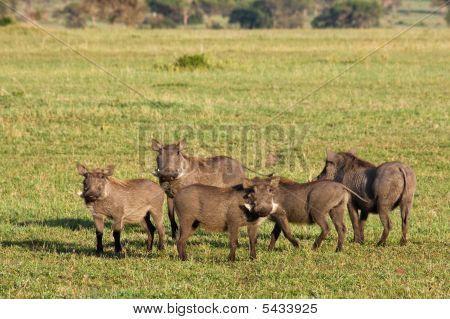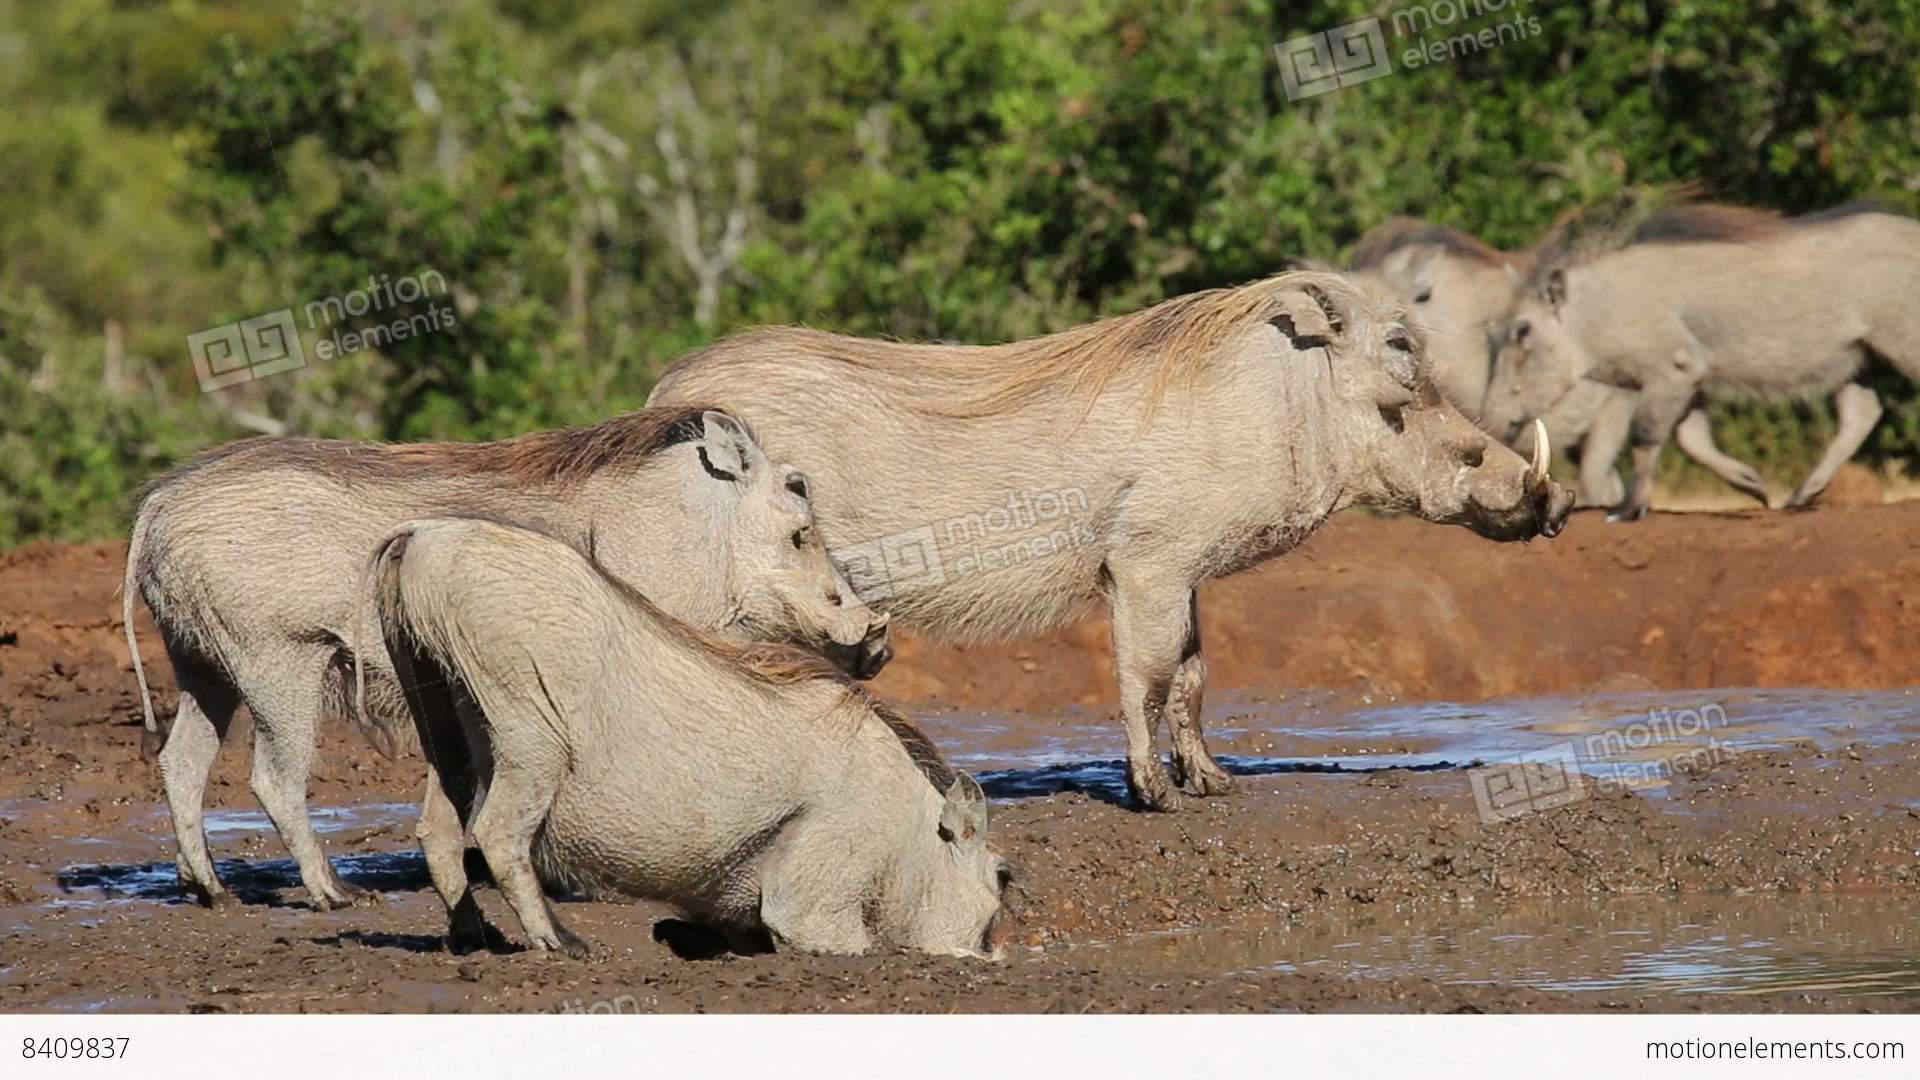The first image is the image on the left, the second image is the image on the right. Examine the images to the left and right. Is the description "There are at least five black animals in the image on the right." accurate? Answer yes or no. No. 